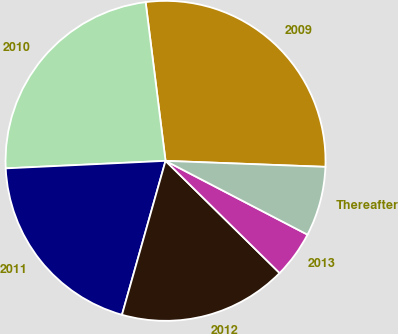<chart> <loc_0><loc_0><loc_500><loc_500><pie_chart><fcel>2009<fcel>2010<fcel>2011<fcel>2012<fcel>2013<fcel>Thereafter<nl><fcel>27.58%<fcel>23.76%<fcel>19.86%<fcel>17.02%<fcel>4.74%<fcel>7.03%<nl></chart> 